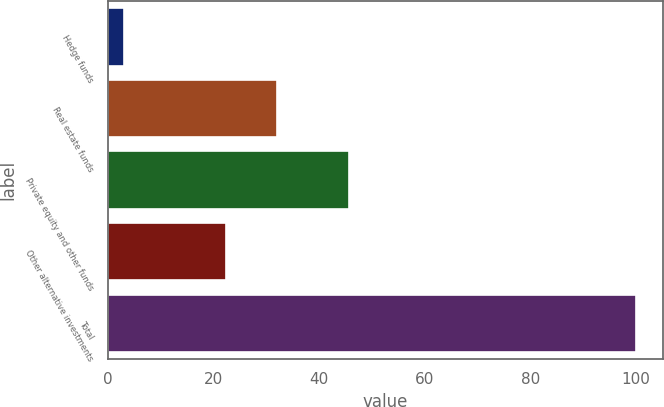Convert chart to OTSL. <chart><loc_0><loc_0><loc_500><loc_500><bar_chart><fcel>Hedge funds<fcel>Real estate funds<fcel>Private equity and other funds<fcel>Other alternative investments<fcel>Total<nl><fcel>3<fcel>32<fcel>45.7<fcel>22.3<fcel>100<nl></chart> 